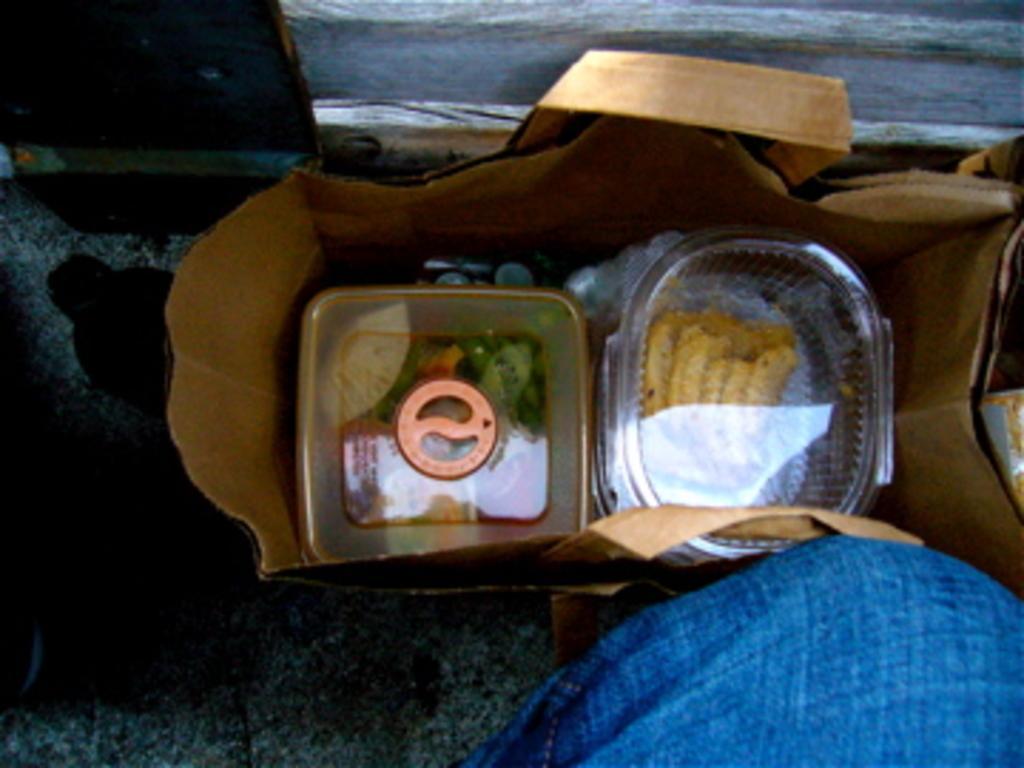Can you describe this image briefly? In this image, I can see a bag, with the boxes, which contains the food items. At the bottom of the image, I think this is a person. This looks like a wooden board. I can see an object beside the bag. 